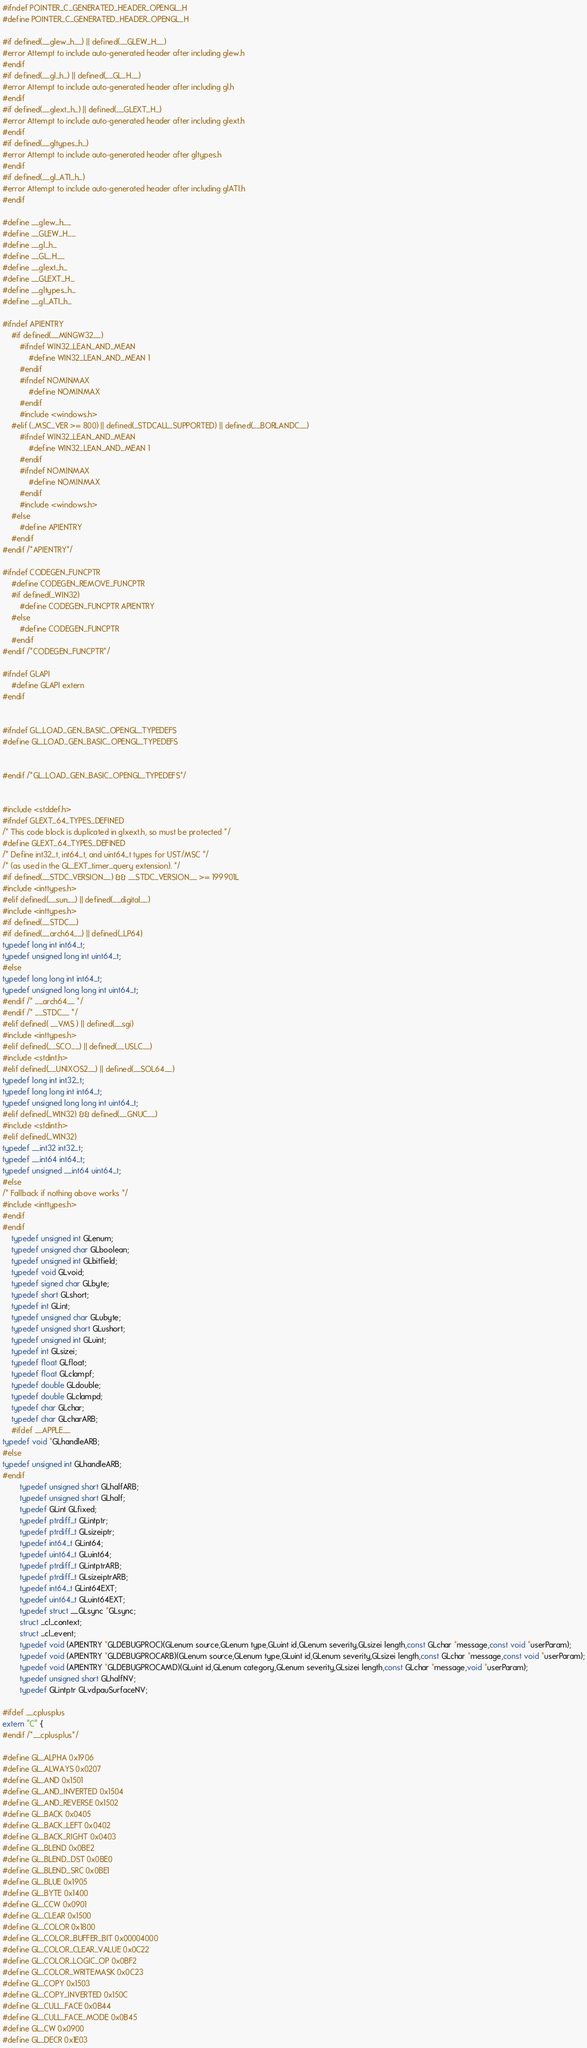Convert code to text. <code><loc_0><loc_0><loc_500><loc_500><_C_>#ifndef POINTER_C_GENERATED_HEADER_OPENGL_H
#define POINTER_C_GENERATED_HEADER_OPENGL_H

#if defined(__glew_h__) || defined(__GLEW_H__)
#error Attempt to include auto-generated header after including glew.h
#endif
#if defined(__gl_h_) || defined(__GL_H__)
#error Attempt to include auto-generated header after including gl.h
#endif
#if defined(__glext_h_) || defined(__GLEXT_H_)
#error Attempt to include auto-generated header after including glext.h
#endif
#if defined(__gltypes_h_)
#error Attempt to include auto-generated header after gltypes.h
#endif
#if defined(__gl_ATI_h_)
#error Attempt to include auto-generated header after including glATI.h
#endif

#define __glew_h__
#define __GLEW_H__
#define __gl_h_
#define __GL_H__
#define __glext_h_
#define __GLEXT_H_
#define __gltypes_h_
#define __gl_ATI_h_

#ifndef APIENTRY
	#if defined(__MINGW32__)
		#ifndef WIN32_LEAN_AND_MEAN
			#define WIN32_LEAN_AND_MEAN 1
		#endif
		#ifndef NOMINMAX
			#define NOMINMAX
		#endif
		#include <windows.h>
	#elif (_MSC_VER >= 800) || defined(_STDCALL_SUPPORTED) || defined(__BORLANDC__)
		#ifndef WIN32_LEAN_AND_MEAN
			#define WIN32_LEAN_AND_MEAN 1
		#endif
		#ifndef NOMINMAX
			#define NOMINMAX
		#endif
		#include <windows.h>
	#else
		#define APIENTRY
	#endif
#endif /*APIENTRY*/

#ifndef CODEGEN_FUNCPTR
	#define CODEGEN_REMOVE_FUNCPTR
	#if defined(_WIN32)
		#define CODEGEN_FUNCPTR APIENTRY
	#else
		#define CODEGEN_FUNCPTR
	#endif
#endif /*CODEGEN_FUNCPTR*/

#ifndef GLAPI
	#define GLAPI extern
#endif


#ifndef GL_LOAD_GEN_BASIC_OPENGL_TYPEDEFS
#define GL_LOAD_GEN_BASIC_OPENGL_TYPEDEFS


#endif /*GL_LOAD_GEN_BASIC_OPENGL_TYPEDEFS*/


#include <stddef.h>
#ifndef GLEXT_64_TYPES_DEFINED
/* This code block is duplicated in glxext.h, so must be protected */
#define GLEXT_64_TYPES_DEFINED
/* Define int32_t, int64_t, and uint64_t types for UST/MSC */
/* (as used in the GL_EXT_timer_query extension). */
#if defined(__STDC_VERSION__) && __STDC_VERSION__ >= 199901L
#include <inttypes.h>
#elif defined(__sun__) || defined(__digital__)
#include <inttypes.h>
#if defined(__STDC__)
#if defined(__arch64__) || defined(_LP64)
typedef long int int64_t;
typedef unsigned long int uint64_t;
#else
typedef long long int int64_t;
typedef unsigned long long int uint64_t;
#endif /* __arch64__ */
#endif /* __STDC__ */
#elif defined( __VMS ) || defined(__sgi)
#include <inttypes.h>
#elif defined(__SCO__) || defined(__USLC__)
#include <stdint.h>
#elif defined(__UNIXOS2__) || defined(__SOL64__)
typedef long int int32_t;
typedef long long int int64_t;
typedef unsigned long long int uint64_t;
#elif defined(_WIN32) && defined(__GNUC__)
#include <stdint.h>
#elif defined(_WIN32)
typedef __int32 int32_t;
typedef __int64 int64_t;
typedef unsigned __int64 uint64_t;
#else
/* Fallback if nothing above works */
#include <inttypes.h>
#endif
#endif
	typedef unsigned int GLenum;
	typedef unsigned char GLboolean;
	typedef unsigned int GLbitfield;
	typedef void GLvoid;
	typedef signed char GLbyte;
	typedef short GLshort;
	typedef int GLint;
	typedef unsigned char GLubyte;
	typedef unsigned short GLushort;
	typedef unsigned int GLuint;
	typedef int GLsizei;
	typedef float GLfloat;
	typedef float GLclampf;
	typedef double GLdouble;
	typedef double GLclampd;
	typedef char GLchar;
	typedef char GLcharARB;
	#ifdef __APPLE__
typedef void *GLhandleARB;
#else
typedef unsigned int GLhandleARB;
#endif
		typedef unsigned short GLhalfARB;
		typedef unsigned short GLhalf;
		typedef GLint GLfixed;
		typedef ptrdiff_t GLintptr;
		typedef ptrdiff_t GLsizeiptr;
		typedef int64_t GLint64;
		typedef uint64_t GLuint64;
		typedef ptrdiff_t GLintptrARB;
		typedef ptrdiff_t GLsizeiptrARB;
		typedef int64_t GLint64EXT;
		typedef uint64_t GLuint64EXT;
		typedef struct __GLsync *GLsync;
		struct _cl_context;
		struct _cl_event;
		typedef void (APIENTRY *GLDEBUGPROC)(GLenum source,GLenum type,GLuint id,GLenum severity,GLsizei length,const GLchar *message,const void *userParam);
		typedef void (APIENTRY *GLDEBUGPROCARB)(GLenum source,GLenum type,GLuint id,GLenum severity,GLsizei length,const GLchar *message,const void *userParam);
		typedef void (APIENTRY *GLDEBUGPROCAMD)(GLuint id,GLenum category,GLenum severity,GLsizei length,const GLchar *message,void *userParam);
		typedef unsigned short GLhalfNV;
		typedef GLintptr GLvdpauSurfaceNV;

#ifdef __cplusplus
extern "C" {
#endif /*__cplusplus*/

#define GL_ALPHA 0x1906
#define GL_ALWAYS 0x0207
#define GL_AND 0x1501
#define GL_AND_INVERTED 0x1504
#define GL_AND_REVERSE 0x1502
#define GL_BACK 0x0405
#define GL_BACK_LEFT 0x0402
#define GL_BACK_RIGHT 0x0403
#define GL_BLEND 0x0BE2
#define GL_BLEND_DST 0x0BE0
#define GL_BLEND_SRC 0x0BE1
#define GL_BLUE 0x1905
#define GL_BYTE 0x1400
#define GL_CCW 0x0901
#define GL_CLEAR 0x1500
#define GL_COLOR 0x1800
#define GL_COLOR_BUFFER_BIT 0x00004000
#define GL_COLOR_CLEAR_VALUE 0x0C22
#define GL_COLOR_LOGIC_OP 0x0BF2
#define GL_COLOR_WRITEMASK 0x0C23
#define GL_COPY 0x1503
#define GL_COPY_INVERTED 0x150C
#define GL_CULL_FACE 0x0B44
#define GL_CULL_FACE_MODE 0x0B45
#define GL_CW 0x0900
#define GL_DECR 0x1E03</code> 